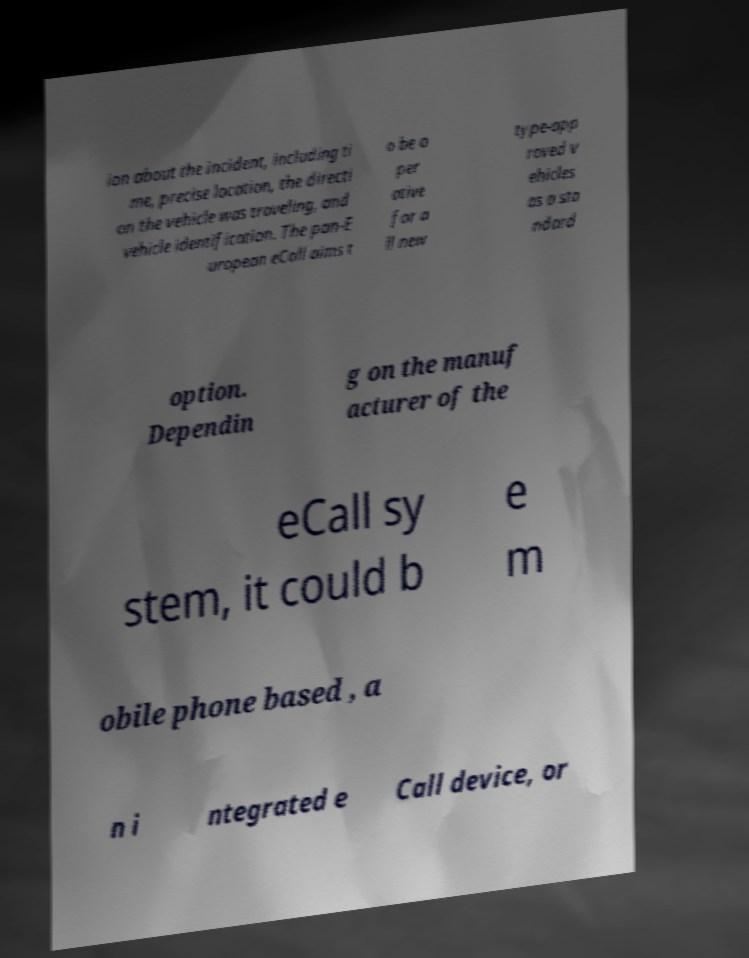Could you assist in decoding the text presented in this image and type it out clearly? ion about the incident, including ti me, precise location, the directi on the vehicle was traveling, and vehicle identification. The pan-E uropean eCall aims t o be o per ative for a ll new type-app roved v ehicles as a sta ndard option. Dependin g on the manuf acturer of the eCall sy stem, it could b e m obile phone based , a n i ntegrated e Call device, or 